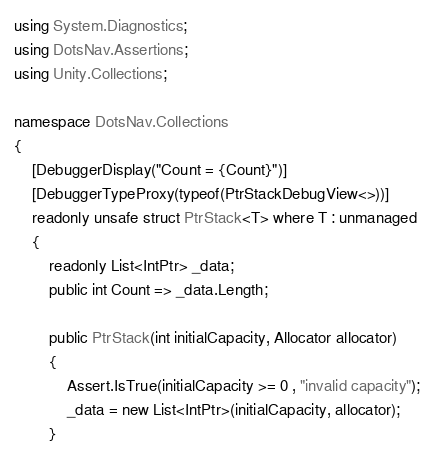<code> <loc_0><loc_0><loc_500><loc_500><_C#_>using System.Diagnostics;
using DotsNav.Assertions;
using Unity.Collections;

namespace DotsNav.Collections
{
    [DebuggerDisplay("Count = {Count}")]
    [DebuggerTypeProxy(typeof(PtrStackDebugView<>))]
    readonly unsafe struct PtrStack<T> where T : unmanaged
    {
        readonly List<IntPtr> _data;
        public int Count => _data.Length;

        public PtrStack(int initialCapacity, Allocator allocator)
        {
            Assert.IsTrue(initialCapacity >= 0 , "invalid capacity");
            _data = new List<IntPtr>(initialCapacity, allocator);
        }
</code> 